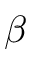Convert formula to latex. <formula><loc_0><loc_0><loc_500><loc_500>\beta</formula> 